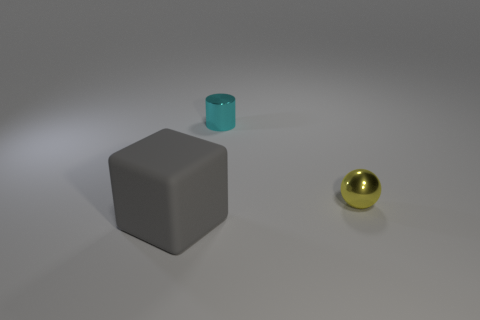Can you describe the placement of the objects in relation to one another? The three objects are placed on a flat surface with ample space between them. The grey cube is nearest to the viewpoint, with the small green metallic cylinder a little further back to the left, and the golden sphere is the farthest away to the right. 